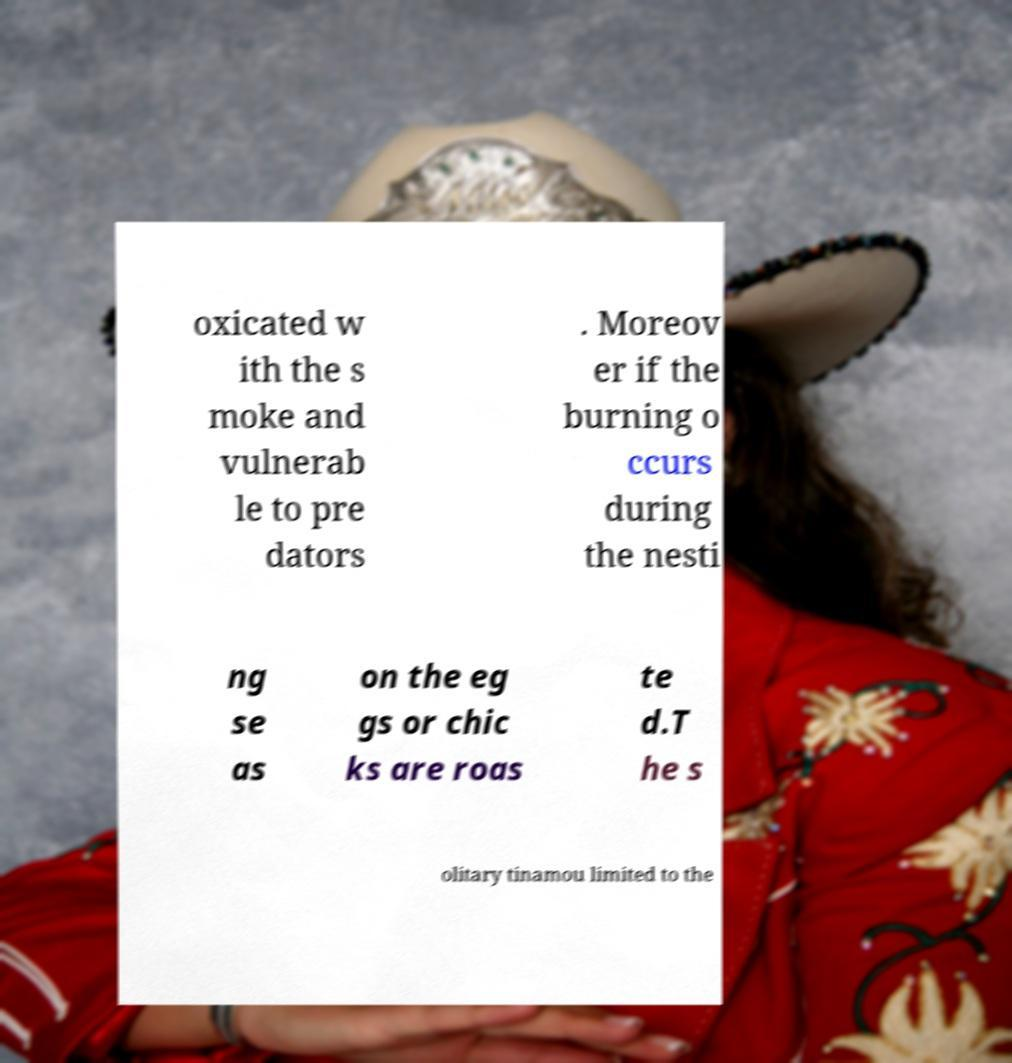Please identify and transcribe the text found in this image. oxicated w ith the s moke and vulnerab le to pre dators . Moreov er if the burning o ccurs during the nesti ng se as on the eg gs or chic ks are roas te d.T he s olitary tinamou limited to the 